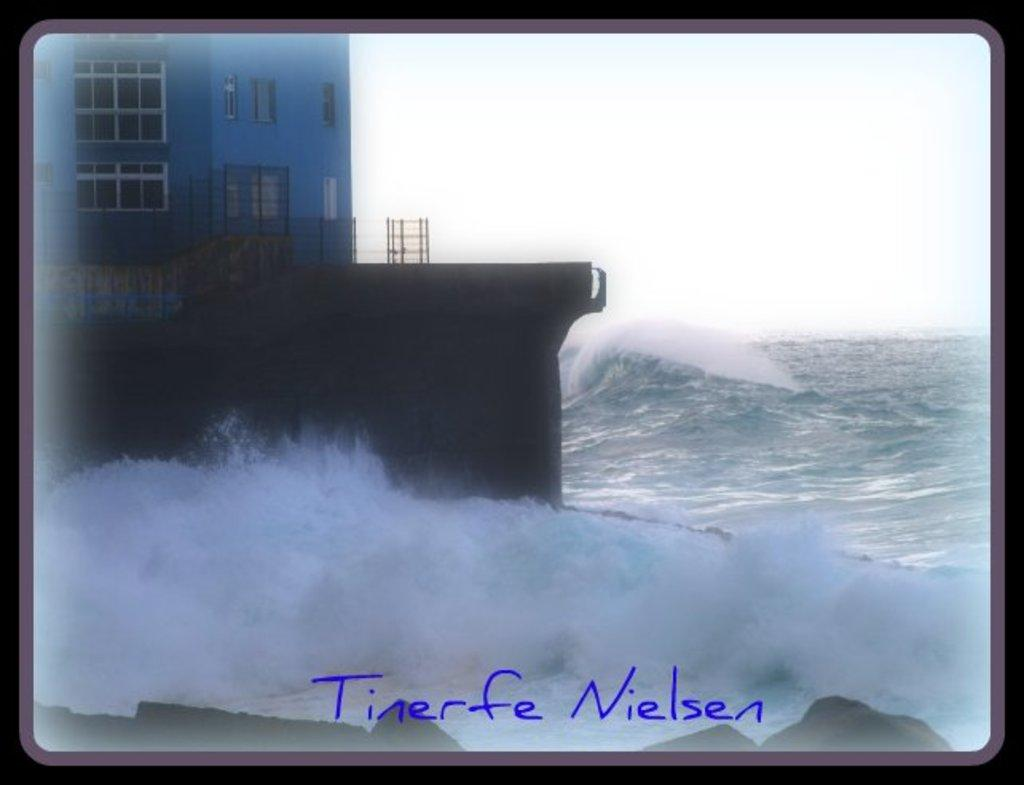What is located on the left side of the image? There is a ship on the left side of the image. Where is the ship situated in the image? The ship is in the water. What else can be seen in the image besides the ship? There is water visible in the image. What is visible at the top of the image? The sky is visible at the top of the image. How many kittens are playing on the truck in the image? There is no truck or kittens present in the image. What type of motion is the ship exhibiting in the image? The image does not show any motion of the ship; it is stationary in the water. 